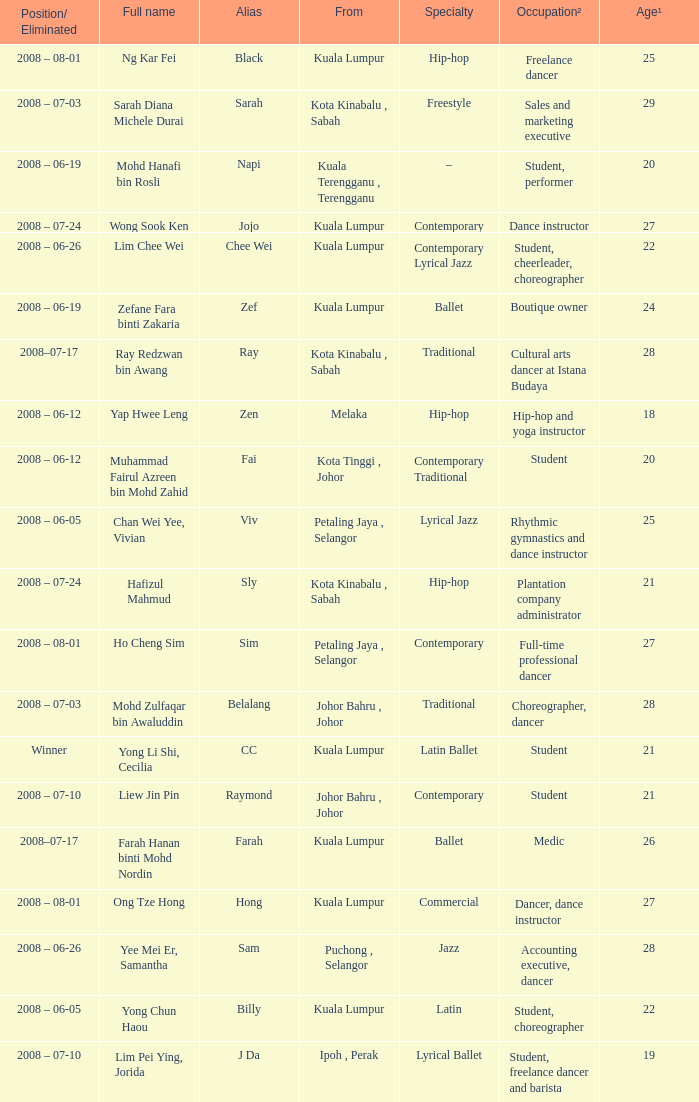What is Position/ Eliminated, when Age¹ is less than 22, and when Full Name is "Muhammad Fairul Azreen Bin Mohd Zahid"? 2008 – 06-12. Could you parse the entire table? {'header': ['Position/ Eliminated', 'Full name', 'Alias', 'From', 'Specialty', 'Occupation²', 'Age¹'], 'rows': [['2008 – 08-01', 'Ng Kar Fei', 'Black', 'Kuala Lumpur', 'Hip-hop', 'Freelance dancer', '25'], ['2008 – 07-03', 'Sarah Diana Michele Durai', 'Sarah', 'Kota Kinabalu , Sabah', 'Freestyle', 'Sales and marketing executive', '29'], ['2008 – 06-19', 'Mohd Hanafi bin Rosli', 'Napi', 'Kuala Terengganu , Terengganu', '–', 'Student, performer', '20'], ['2008 – 07-24', 'Wong Sook Ken', 'Jojo', 'Kuala Lumpur', 'Contemporary', 'Dance instructor', '27'], ['2008 – 06-26', 'Lim Chee Wei', 'Chee Wei', 'Kuala Lumpur', 'Contemporary Lyrical Jazz', 'Student, cheerleader, choreographer', '22'], ['2008 – 06-19', 'Zefane Fara binti Zakaria', 'Zef', 'Kuala Lumpur', 'Ballet', 'Boutique owner', '24'], ['2008–07-17', 'Ray Redzwan bin Awang', 'Ray', 'Kota Kinabalu , Sabah', 'Traditional', 'Cultural arts dancer at Istana Budaya', '28'], ['2008 – 06-12', 'Yap Hwee Leng', 'Zen', 'Melaka', 'Hip-hop', 'Hip-hop and yoga instructor', '18'], ['2008 – 06-12', 'Muhammad Fairul Azreen bin Mohd Zahid', 'Fai', 'Kota Tinggi , Johor', 'Contemporary Traditional', 'Student', '20'], ['2008 – 06-05', 'Chan Wei Yee, Vivian', 'Viv', 'Petaling Jaya , Selangor', 'Lyrical Jazz', 'Rhythmic gymnastics and dance instructor', '25'], ['2008 – 07-24', 'Hafizul Mahmud', 'Sly', 'Kota Kinabalu , Sabah', 'Hip-hop', 'Plantation company administrator', '21'], ['2008 – 08-01', 'Ho Cheng Sim', 'Sim', 'Petaling Jaya , Selangor', 'Contemporary', 'Full-time professional dancer', '27'], ['2008 – 07-03', 'Mohd Zulfaqar bin Awaluddin', 'Belalang', 'Johor Bahru , Johor', 'Traditional', 'Choreographer, dancer', '28'], ['Winner', 'Yong Li Shi, Cecilia', 'CC', 'Kuala Lumpur', 'Latin Ballet', 'Student', '21'], ['2008 – 07-10', 'Liew Jin Pin', 'Raymond', 'Johor Bahru , Johor', 'Contemporary', 'Student', '21'], ['2008–07-17', 'Farah Hanan binti Mohd Nordin', 'Farah', 'Kuala Lumpur', 'Ballet', 'Medic', '26'], ['2008 – 08-01', 'Ong Tze Hong', 'Hong', 'Kuala Lumpur', 'Commercial', 'Dancer, dance instructor', '27'], ['2008 – 06-26', 'Yee Mei Er, Samantha', 'Sam', 'Puchong , Selangor', 'Jazz', 'Accounting executive, dancer', '28'], ['2008 – 06-05', 'Yong Chun Haou', 'Billy', 'Kuala Lumpur', 'Latin', 'Student, choreographer', '22'], ['2008 – 07-10', 'Lim Pei Ying, Jorida', 'J Da', 'Ipoh , Perak', 'Lyrical Ballet', 'Student, freelance dancer and barista', '19']]} 